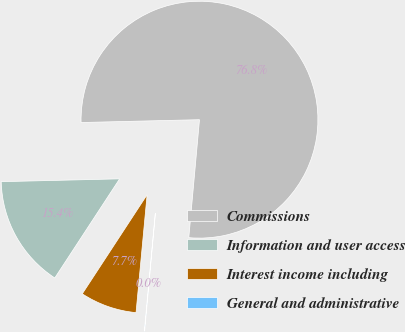<chart> <loc_0><loc_0><loc_500><loc_500><pie_chart><fcel>Commissions<fcel>Information and user access<fcel>Interest income including<fcel>General and administrative<nl><fcel>76.82%<fcel>15.4%<fcel>7.73%<fcel>0.05%<nl></chart> 